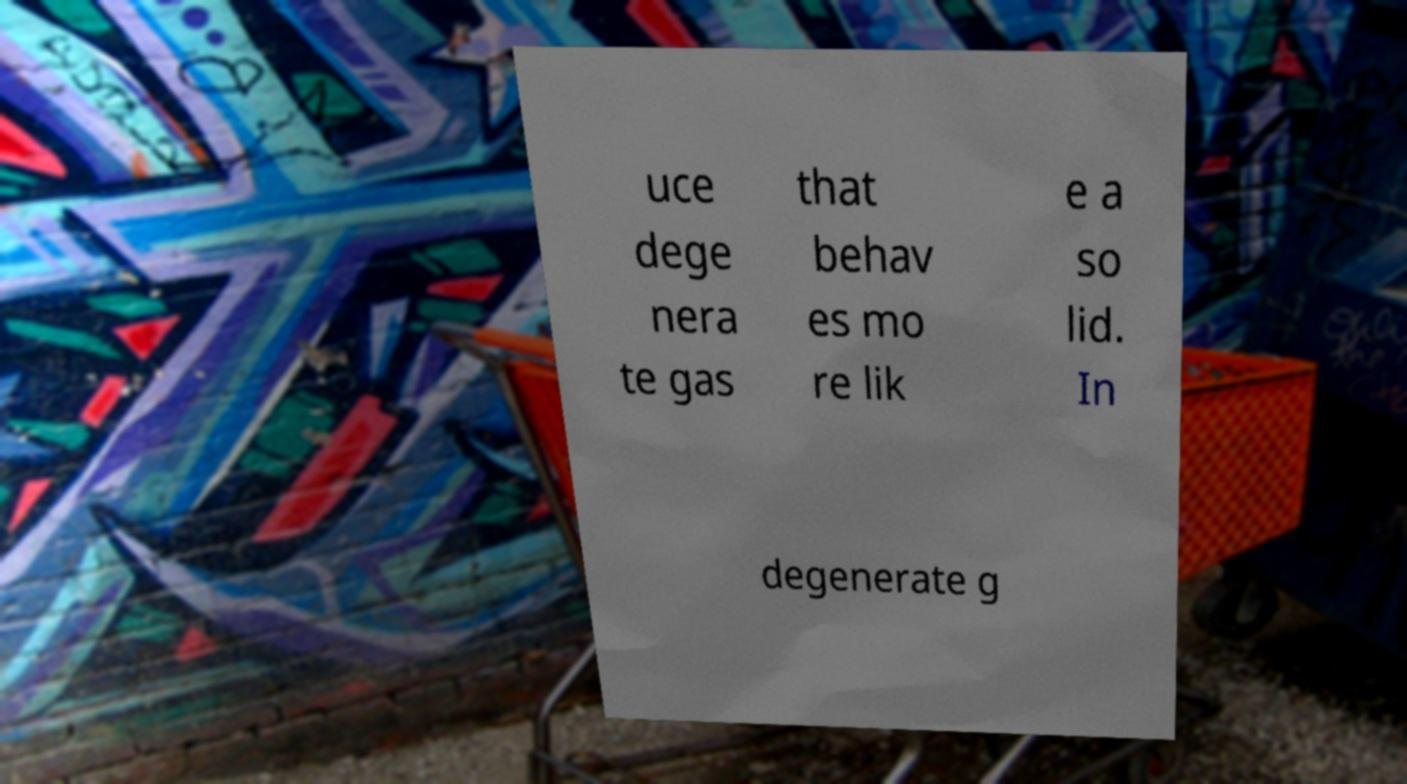Could you assist in decoding the text presented in this image and type it out clearly? uce dege nera te gas that behav es mo re lik e a so lid. In degenerate g 